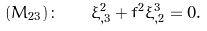Convert formula to latex. <formula><loc_0><loc_0><loc_500><loc_500>( M _ { 2 3 } ) \colon \quad \xi ^ { 2 } _ { , 3 } + f ^ { 2 } \xi ^ { 3 } _ { , 2 } = 0 .</formula> 